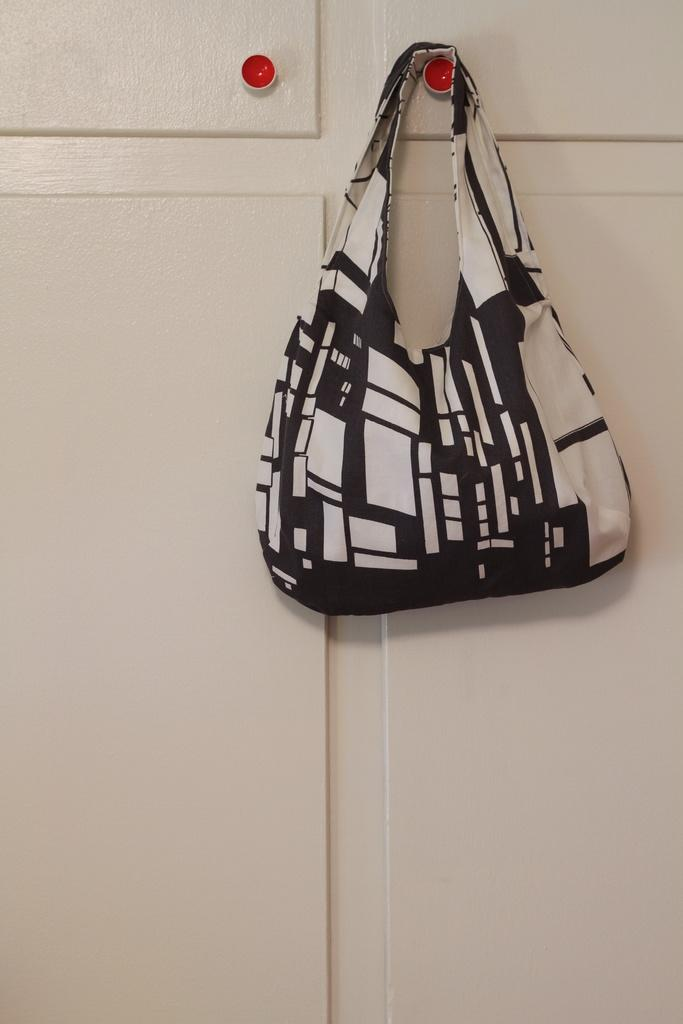What object is the main focus of the image? The image shows a woman's handbag. Can you describe the handbag in the image? The image only shows a woman's handbag, so we cannot provide a detailed description of its appearance. What might be inside the handbag? We cannot determine what is inside the handbag from the image alone. How many buttons are attached to the line in the image? There is no line or button present in the image; it only shows a woman's handbag. 